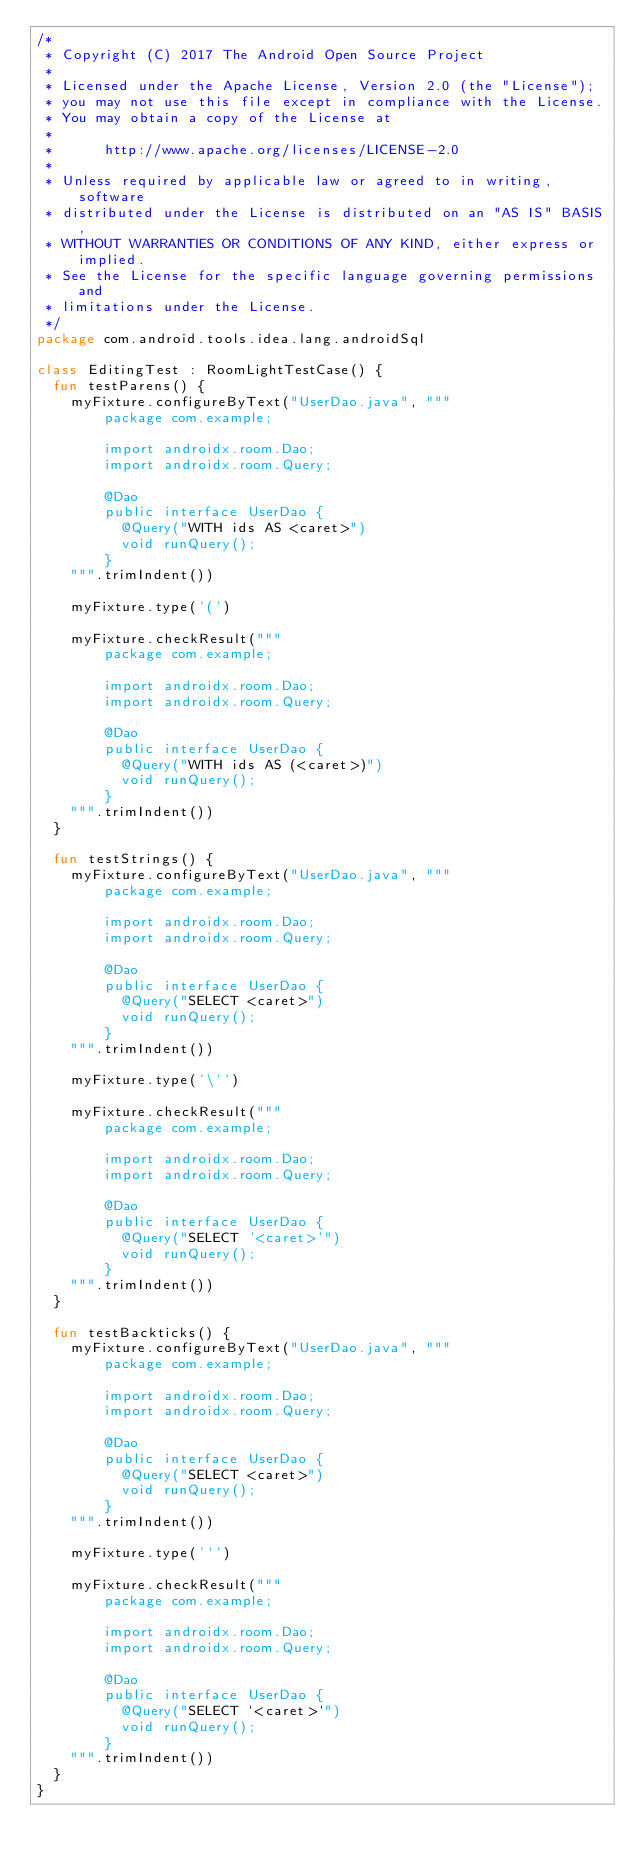<code> <loc_0><loc_0><loc_500><loc_500><_Kotlin_>/*
 * Copyright (C) 2017 The Android Open Source Project
 *
 * Licensed under the Apache License, Version 2.0 (the "License");
 * you may not use this file except in compliance with the License.
 * You may obtain a copy of the License at
 *
 *      http://www.apache.org/licenses/LICENSE-2.0
 *
 * Unless required by applicable law or agreed to in writing, software
 * distributed under the License is distributed on an "AS IS" BASIS,
 * WITHOUT WARRANTIES OR CONDITIONS OF ANY KIND, either express or implied.
 * See the License for the specific language governing permissions and
 * limitations under the License.
 */
package com.android.tools.idea.lang.androidSql

class EditingTest : RoomLightTestCase() {
  fun testParens() {
    myFixture.configureByText("UserDao.java", """
        package com.example;

        import androidx.room.Dao;
        import androidx.room.Query;

        @Dao
        public interface UserDao {
          @Query("WITH ids AS <caret>")
          void runQuery();
        }
    """.trimIndent())

    myFixture.type('(')

    myFixture.checkResult("""
        package com.example;

        import androidx.room.Dao;
        import androidx.room.Query;

        @Dao
        public interface UserDao {
          @Query("WITH ids AS (<caret>)")
          void runQuery();
        }
    """.trimIndent())
  }

  fun testStrings() {
    myFixture.configureByText("UserDao.java", """
        package com.example;

        import androidx.room.Dao;
        import androidx.room.Query;

        @Dao
        public interface UserDao {
          @Query("SELECT <caret>")
          void runQuery();
        }
    """.trimIndent())

    myFixture.type('\'')

    myFixture.checkResult("""
        package com.example;

        import androidx.room.Dao;
        import androidx.room.Query;

        @Dao
        public interface UserDao {
          @Query("SELECT '<caret>'")
          void runQuery();
        }
    """.trimIndent())
  }

  fun testBackticks() {
    myFixture.configureByText("UserDao.java", """
        package com.example;

        import androidx.room.Dao;
        import androidx.room.Query;

        @Dao
        public interface UserDao {
          @Query("SELECT <caret>")
          void runQuery();
        }
    """.trimIndent())

    myFixture.type('`')

    myFixture.checkResult("""
        package com.example;

        import androidx.room.Dao;
        import androidx.room.Query;

        @Dao
        public interface UserDao {
          @Query("SELECT `<caret>`")
          void runQuery();
        }
    """.trimIndent())
  }
}
</code> 